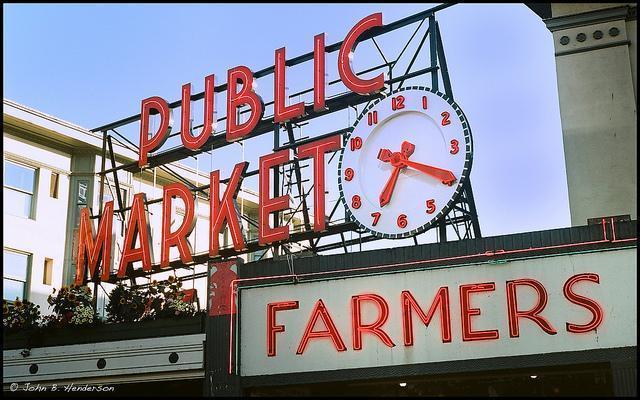How many clocks can you see?
Give a very brief answer. 1. How many people are wearing a white shirt?
Give a very brief answer. 0. 